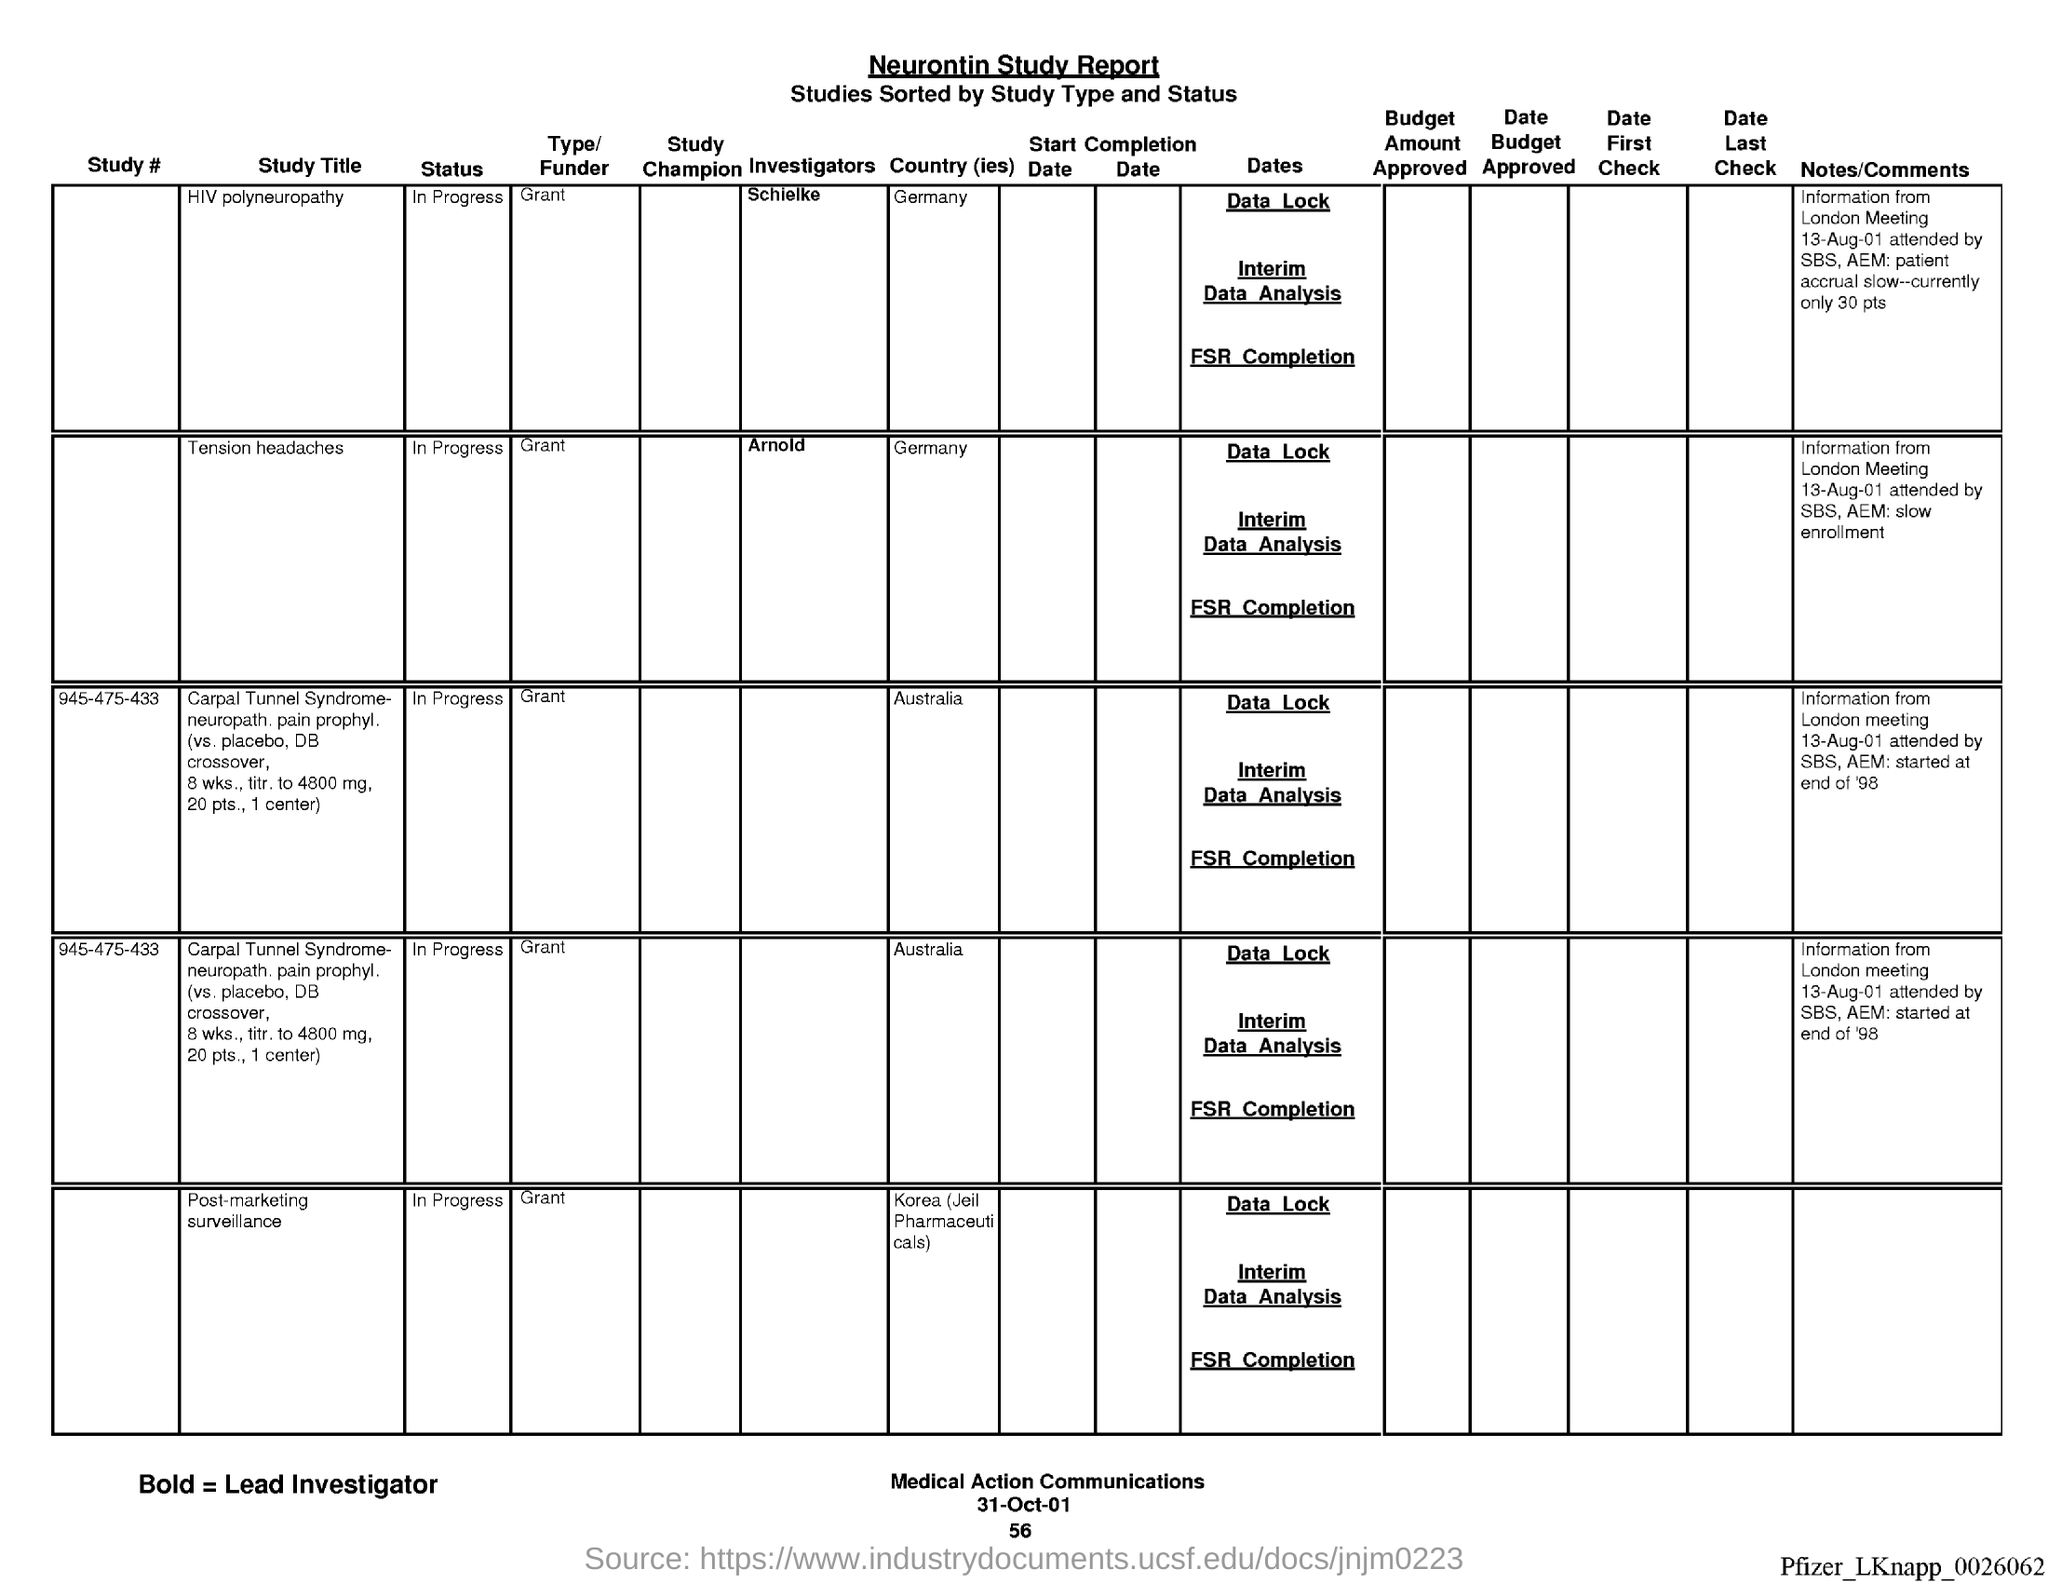What is the Status of Study "HIV polyneuropathy"?
Ensure brevity in your answer.  In Progress. What is the Type/Funder of Study "HIV polyneuropathy"?
Your response must be concise. Grant. What is the Country of Study "HIV polyneuropathy"?
Ensure brevity in your answer.  Germany. What is the Status of Study "Tension Headaches"?
Ensure brevity in your answer.  In progress. What is the Type/Funder of Study "Tension Headaches"?
Ensure brevity in your answer.  Grant. What is the Country of Study "Tension Headaches"?
Offer a very short reply. Germany. What is the Status of Study #945-475-433?
Make the answer very short. In Progress. What is the Type/Funder of Study #945-475-433?
Ensure brevity in your answer.  Grant. What is the Country of Study #945-475-433?
Your response must be concise. Australia. What is the Title of the document?
Provide a short and direct response. Neurontin Study Report. 